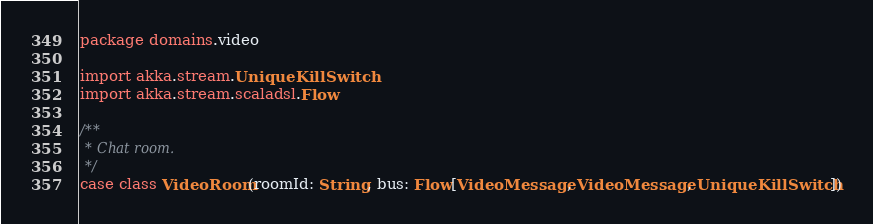Convert code to text. <code><loc_0><loc_0><loc_500><loc_500><_Scala_>package domains.video

import akka.stream.UniqueKillSwitch
import akka.stream.scaladsl.Flow

/**
 * Chat room.
 */
case class VideoRoom(roomId: String, bus: Flow[VideoMessage, VideoMessage, UniqueKillSwitch])
</code> 